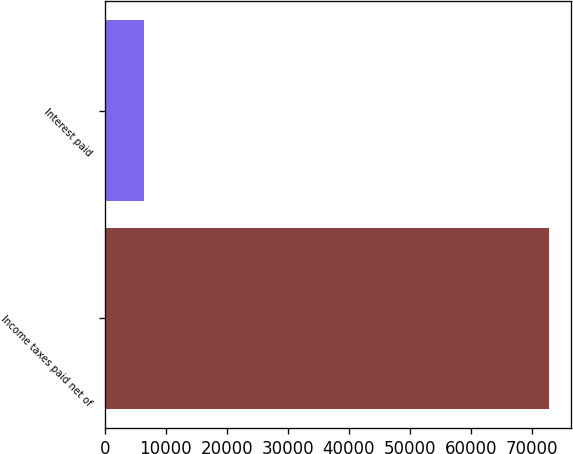<chart> <loc_0><loc_0><loc_500><loc_500><bar_chart><fcel>Income taxes paid net of<fcel>Interest paid<nl><fcel>72827<fcel>6339<nl></chart> 